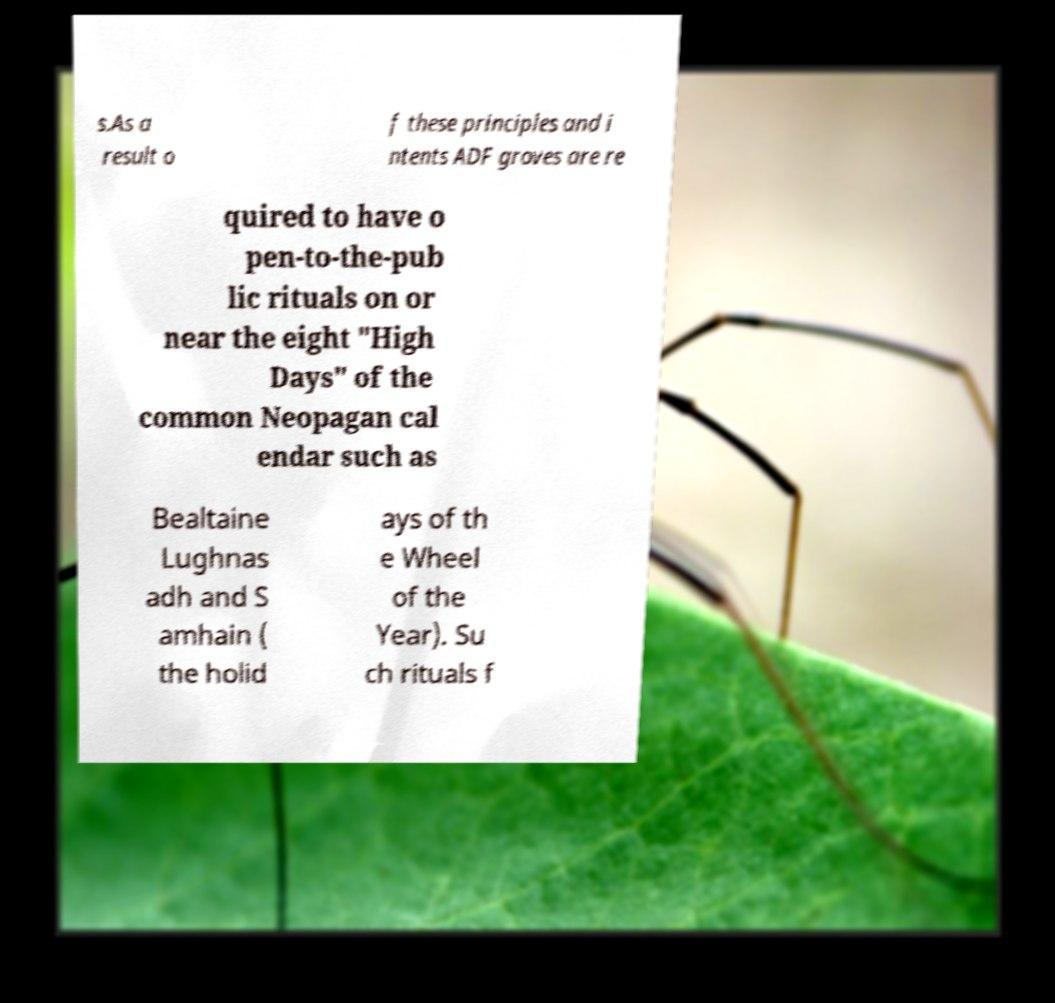For documentation purposes, I need the text within this image transcribed. Could you provide that? s.As a result o f these principles and i ntents ADF groves are re quired to have o pen-to-the-pub lic rituals on or near the eight "High Days" of the common Neopagan cal endar such as Bealtaine Lughnas adh and S amhain ( the holid ays of th e Wheel of the Year). Su ch rituals f 